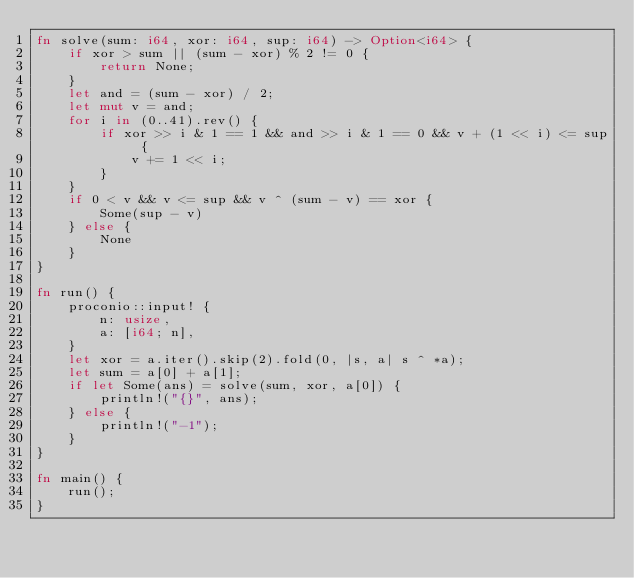Convert code to text. <code><loc_0><loc_0><loc_500><loc_500><_Rust_>fn solve(sum: i64, xor: i64, sup: i64) -> Option<i64> {
    if xor > sum || (sum - xor) % 2 != 0 {
        return None;
    }
    let and = (sum - xor) / 2;
    let mut v = and;
    for i in (0..41).rev() {
        if xor >> i & 1 == 1 && and >> i & 1 == 0 && v + (1 << i) <= sup {
            v += 1 << i;
        }
    }
    if 0 < v && v <= sup && v ^ (sum - v) == xor {
        Some(sup - v)
    } else {
        None
    }
}

fn run() {
    proconio::input! {
        n: usize,
        a: [i64; n],
    }
    let xor = a.iter().skip(2).fold(0, |s, a| s ^ *a);
    let sum = a[0] + a[1];
    if let Some(ans) = solve(sum, xor, a[0]) {
        println!("{}", ans);
    } else {
        println!("-1");
    }
}

fn main() {
    run();
}
</code> 